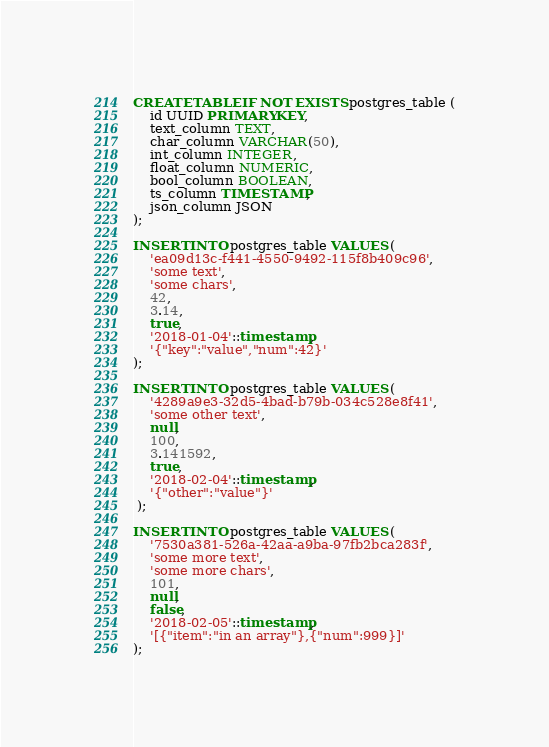Convert code to text. <code><loc_0><loc_0><loc_500><loc_500><_SQL_>CREATE TABLE IF NOT EXISTS postgres_table (
    id UUID PRIMARY KEY,
    text_column TEXT,
    char_column VARCHAR(50),
    int_column INTEGER,
    float_column NUMERIC,
    bool_column BOOLEAN,
    ts_column TIMESTAMP,
    json_column JSON
);

INSERT INTO postgres_table VALUES (
    'ea09d13c-f441-4550-9492-115f8b409c96',
    'some text',
    'some chars',
    42,
    3.14,
    true,
    '2018-01-04'::timestamp,
    '{"key":"value","num":42}'
);

INSERT INTO postgres_table VALUES (
    '4289a9e3-32d5-4bad-b79b-034c528e8f41',
    'some other text',
    null,
    100,
    3.141592,
    true,
    '2018-02-04'::timestamp,
    '{"other":"value"}'
 );

INSERT INTO postgres_table VALUES (
    '7530a381-526a-42aa-a9ba-97fb2bca283f',
    'some more text',
    'some more chars',
    101,
    null,
    false,
    '2018-02-05'::timestamp,
    '[{"item":"in an array"},{"num":999}]'
);</code> 